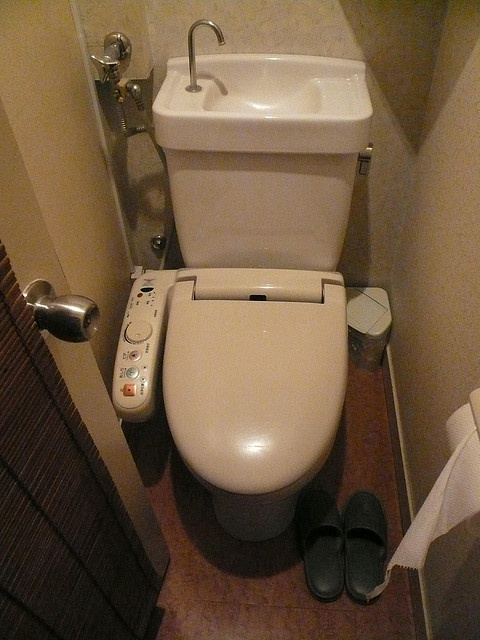Describe the objects in this image and their specific colors. I can see toilet in olive, tan, and black tones and sink in olive, tan, and gray tones in this image. 